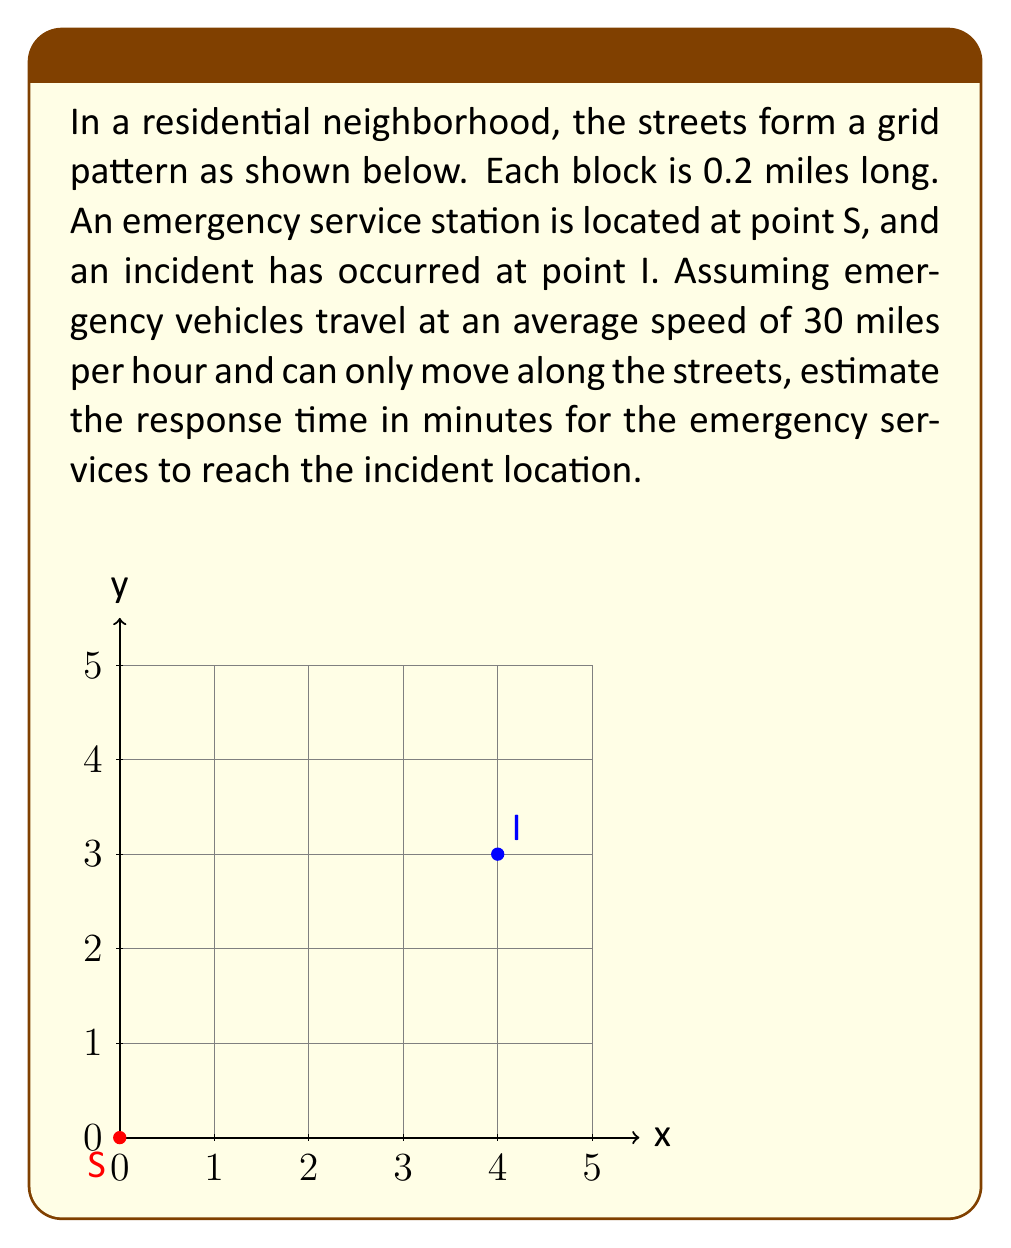Provide a solution to this math problem. To solve this problem, we'll follow these steps:

1) First, we need to determine the shortest path from S to I. In a grid layout, this is known as the Manhattan distance or L1 distance.

2) The Manhattan distance is calculated by summing the absolute differences in the x and y coordinates:
   $$\text{Distance} = |x_I - x_S| + |y_I - y_S|$$

3) From the diagram, we can see that:
   * $x_I - x_S = 4$ blocks
   * $y_I - y_S = 3$ blocks

4) So the total distance is:
   $$\text{Distance} = 4 + 3 = 7 \text{ blocks}$$

5) Each block is 0.2 miles, so the total distance in miles is:
   $$7 \times 0.2 = 1.4 \text{ miles}$$

6) Now we can use the formula: $\text{Time} = \frac{\text{Distance}}{\text{Speed}}$

7) Given: Speed = 30 miles per hour
   $$\text{Time} = \frac{1.4 \text{ miles}}{30 \text{ miles/hour}} = \frac{1.4}{30} \text{ hours}$$

8) Convert hours to minutes:
   $$\frac{1.4}{30} \times 60 \text{ minutes/hour} = 2.8 \text{ minutes}$$

9) Rounding to the nearest tenth of a minute:
   $$2.8 \text{ minutes} \approx 2.8 \text{ minutes}$$
Answer: 2.8 minutes 